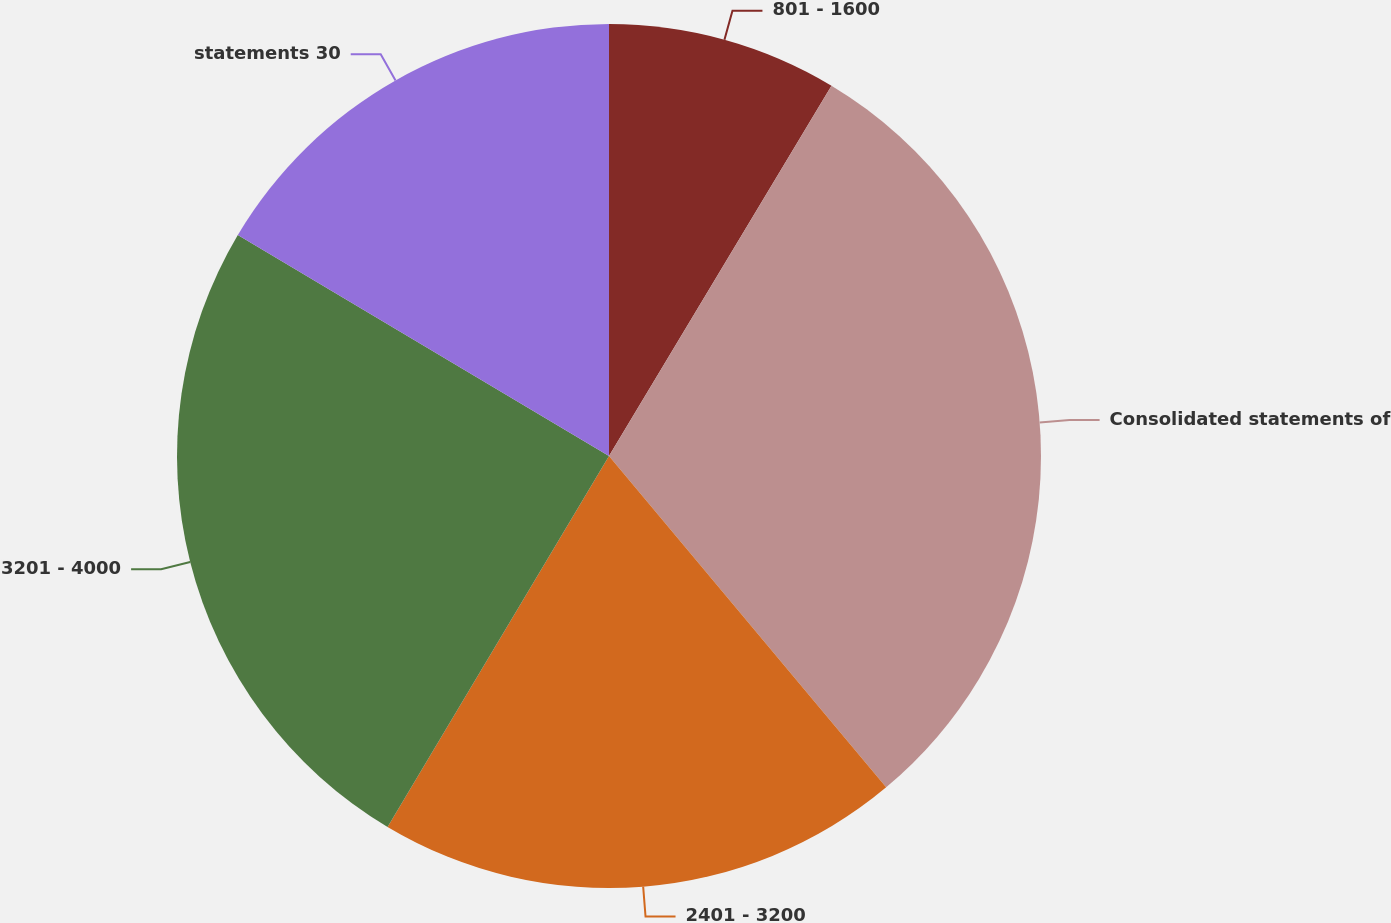Convert chart. <chart><loc_0><loc_0><loc_500><loc_500><pie_chart><fcel>801 - 1600<fcel>Consolidated statements of<fcel>2401 - 3200<fcel>3201 - 4000<fcel>statements 30<nl><fcel>8.61%<fcel>30.3%<fcel>19.65%<fcel>24.98%<fcel>16.45%<nl></chart> 